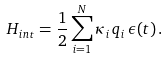Convert formula to latex. <formula><loc_0><loc_0><loc_500><loc_500>H _ { i n t } = \frac { 1 } { 2 } \sum _ { i = 1 } ^ { N } \kappa _ { i } \, q _ { i } \, \epsilon ( t ) \, .</formula> 